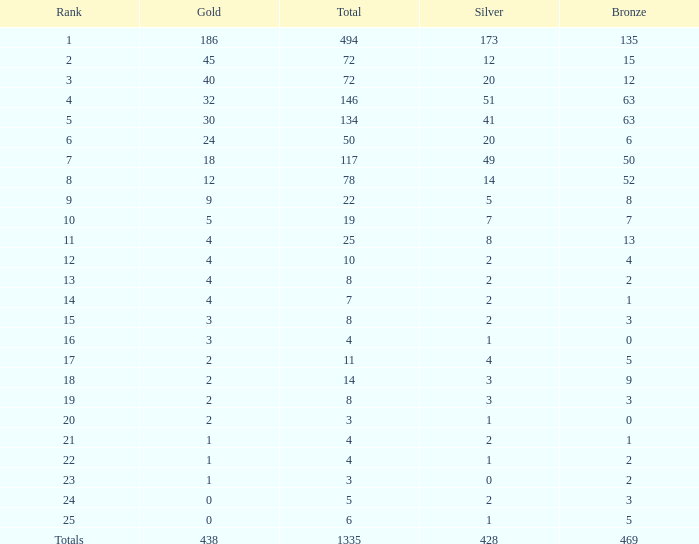What is the total amount of gold medals when there were more than 20 silvers and there were 135 bronze medals? 1.0. 